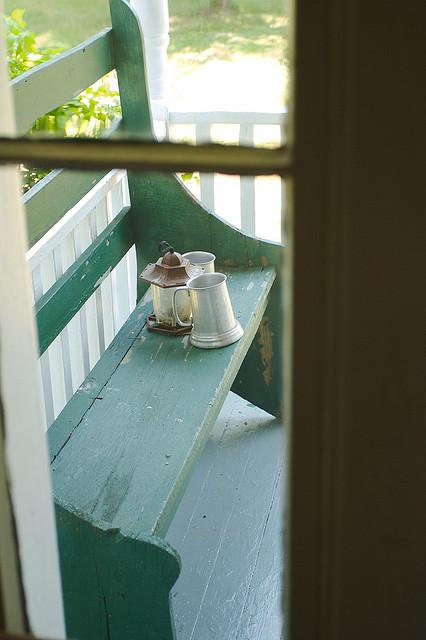What type of drinking vessels are on the bench? Please explain your reasoning. steins. Steins are on the bench. 